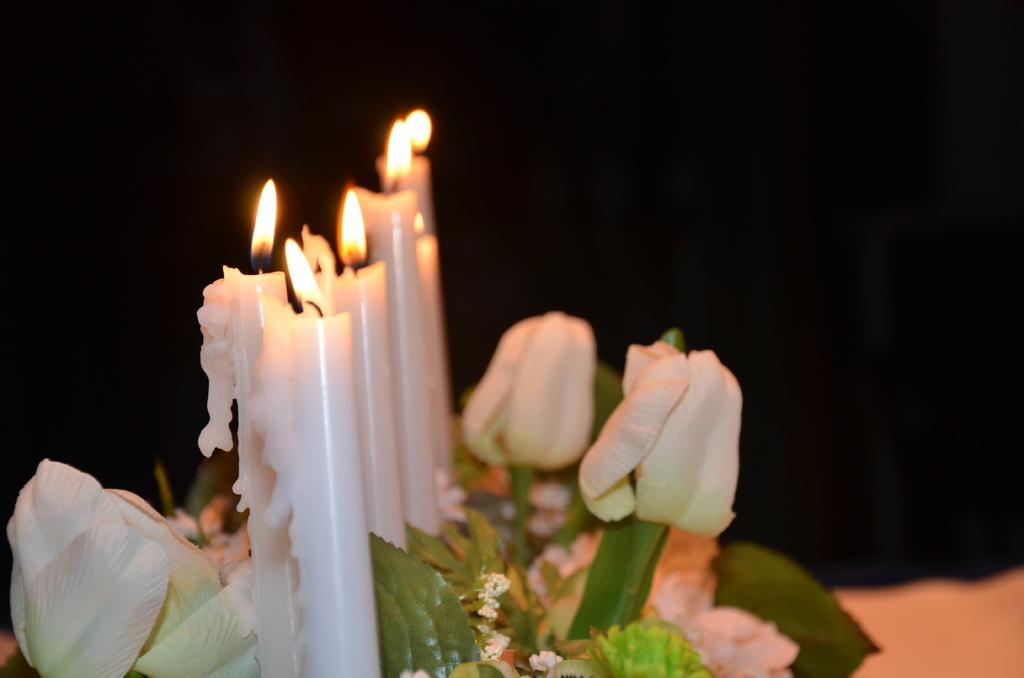What objects can be seen on the left side of the image? There are candles on the left side of the image. What is located at the bottom side of the image? There are flowers at the bottom side of the image. What type of desk is visible in the image? There is no desk present in the image. What is the order of the flowers in the image? The flowers are not arranged in any specific order, as they are simply located at the bottom side of the image. 